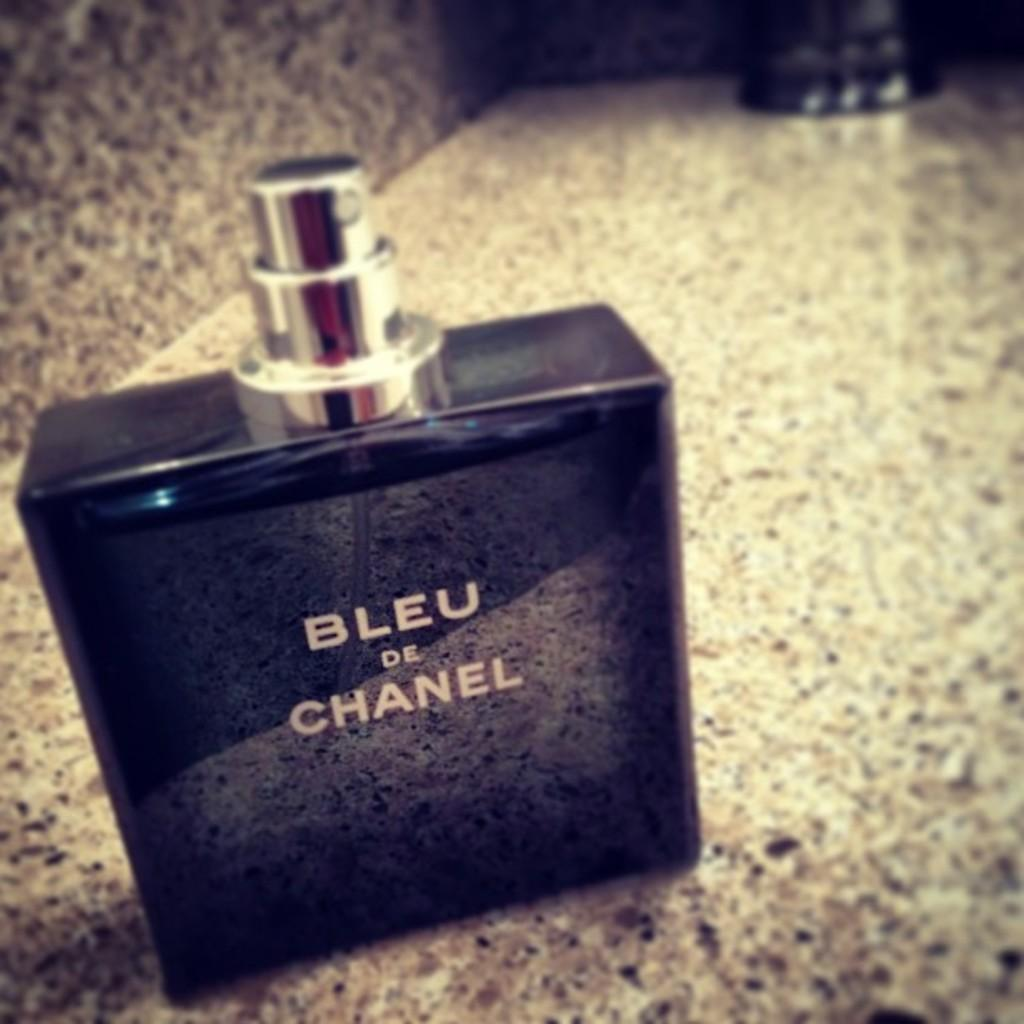<image>
Offer a succinct explanation of the picture presented. A bottle of cologne sitting on a counter with the words Bleu De Chanel on it. 